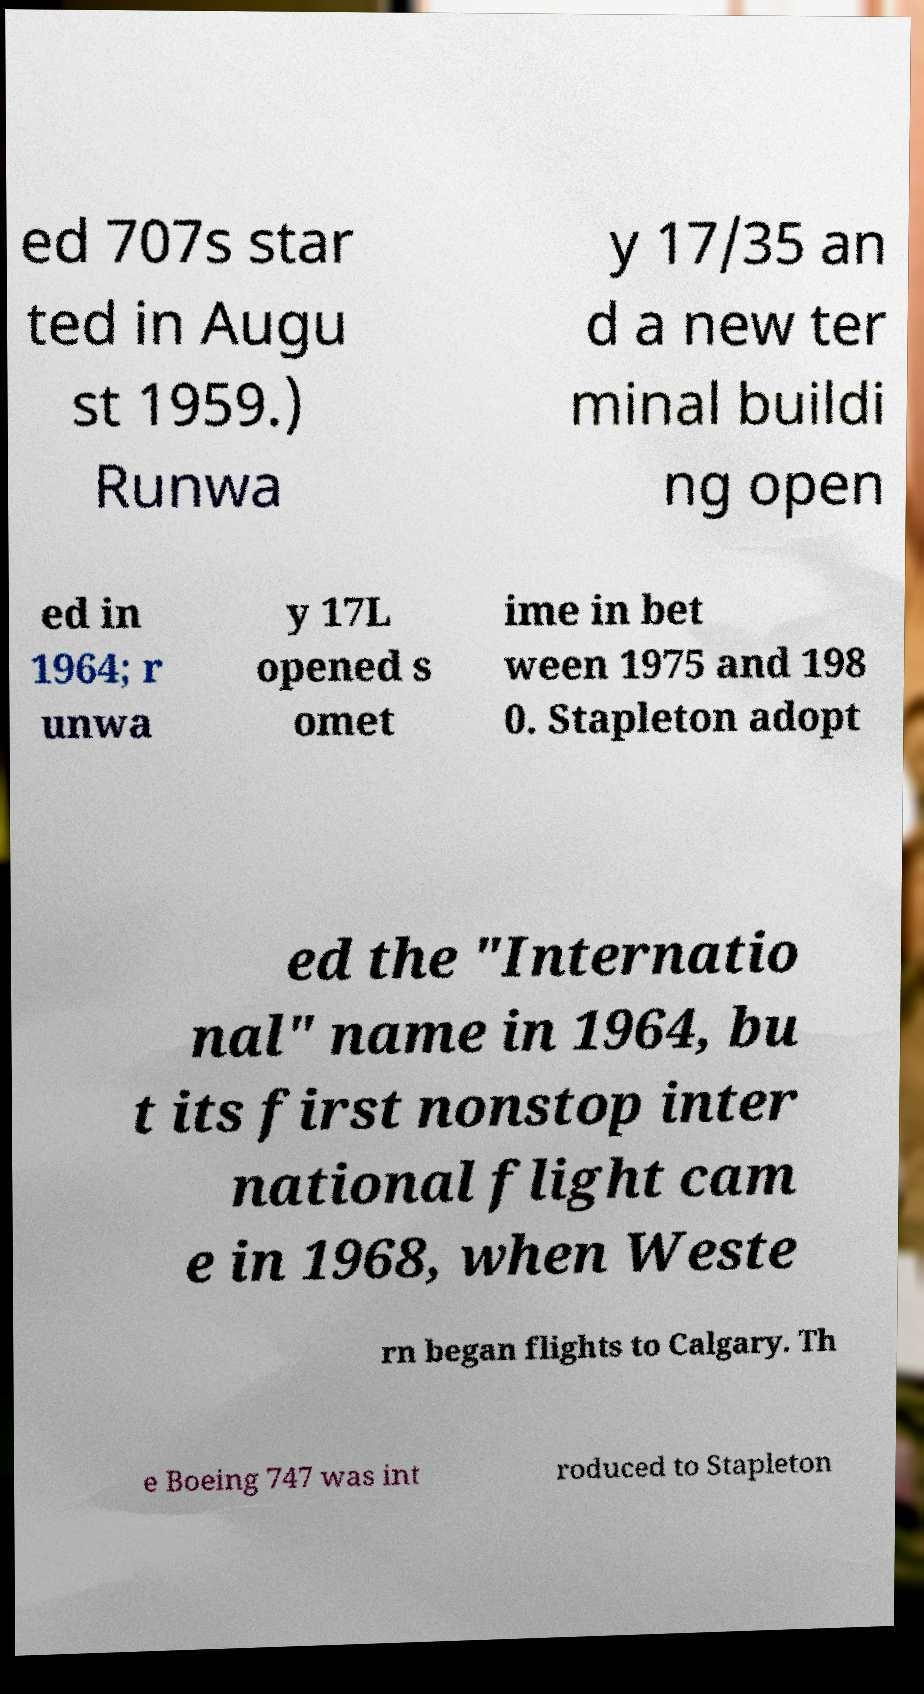Can you read and provide the text displayed in the image?This photo seems to have some interesting text. Can you extract and type it out for me? ed 707s star ted in Augu st 1959.) Runwa y 17/35 an d a new ter minal buildi ng open ed in 1964; r unwa y 17L opened s omet ime in bet ween 1975 and 198 0. Stapleton adopt ed the "Internatio nal" name in 1964, bu t its first nonstop inter national flight cam e in 1968, when Weste rn began flights to Calgary. Th e Boeing 747 was int roduced to Stapleton 